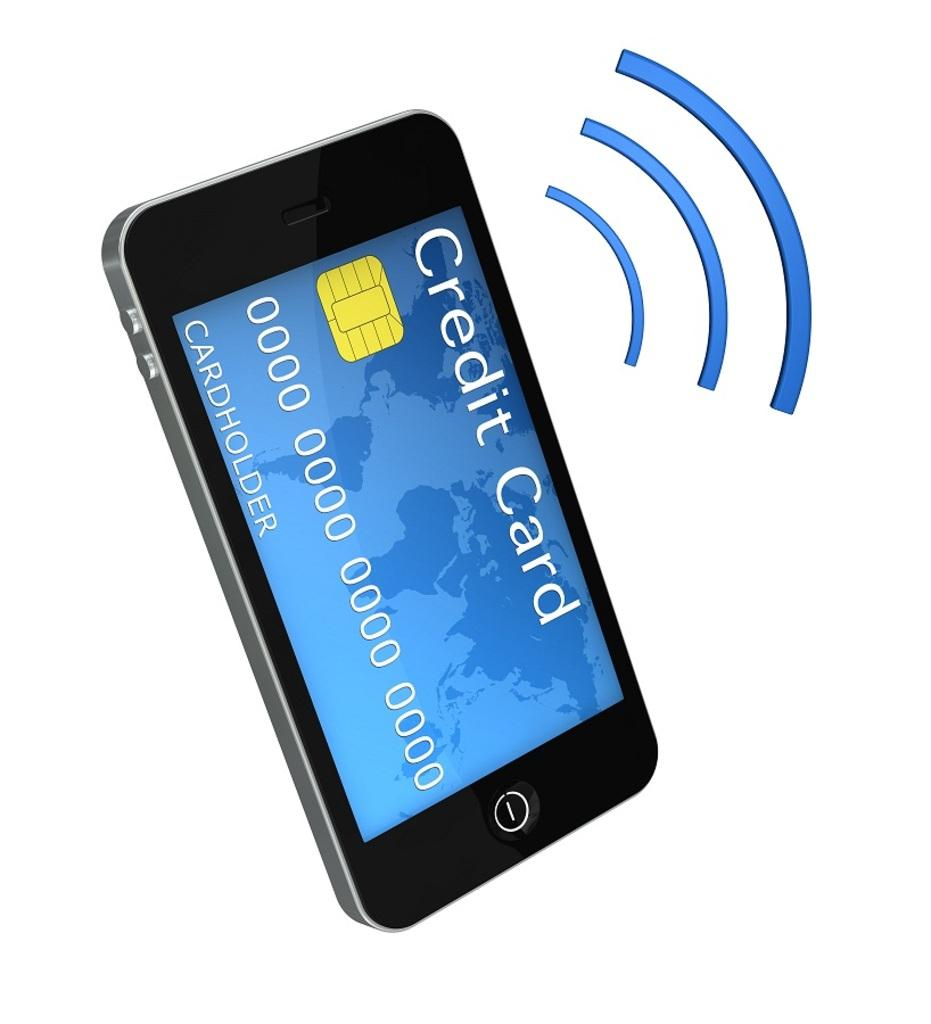<image>
Relay a brief, clear account of the picture shown. A cell phone with a wifi graphic to the right of it with a fake credit card and numbers on the screen. 